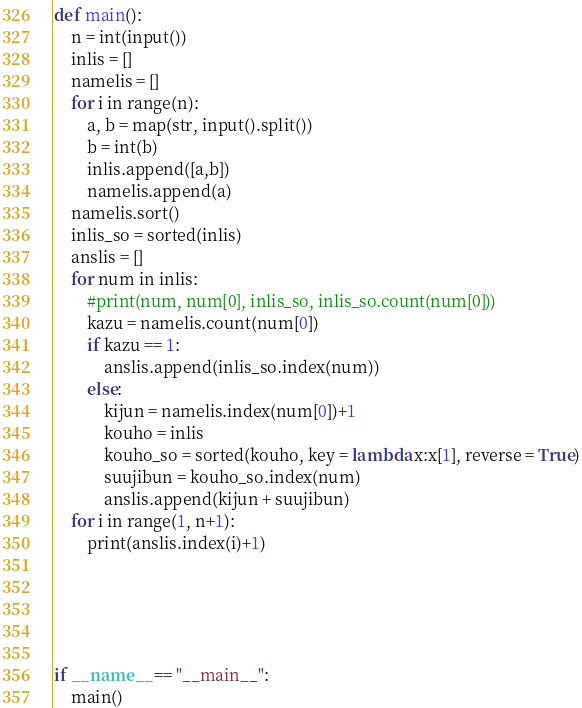<code> <loc_0><loc_0><loc_500><loc_500><_Python_>def main():
    n = int(input())
    inlis = []
    namelis = []
    for i in range(n):
        a, b = map(str, input().split())
        b = int(b)
        inlis.append([a,b])
        namelis.append(a)
    namelis.sort()    
    inlis_so = sorted(inlis)
    anslis = []
    for num in inlis:
        #print(num, num[0], inlis_so, inlis_so.count(num[0]))
        kazu = namelis.count(num[0])
        if kazu == 1:
            anslis.append(inlis_so.index(num))
        else:
            kijun = namelis.index(num[0])+1
            kouho = inlis
            kouho_so = sorted(kouho, key = lambda x:x[1], reverse = True)
            suujibun = kouho_so.index(num)
            anslis.append(kijun + suujibun)
    for i in range(1, n+1):
        print(anslis.index(i)+1)

    

        
    
if __name__ == "__main__":
    main()
</code> 